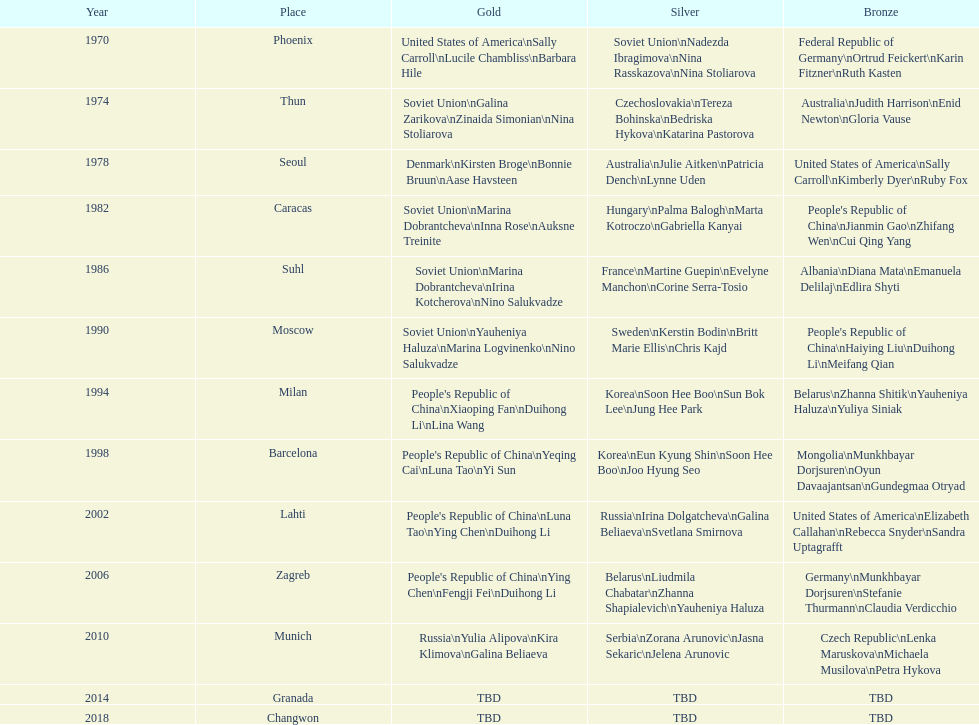What is the first place listed in this chart? Phoenix. 